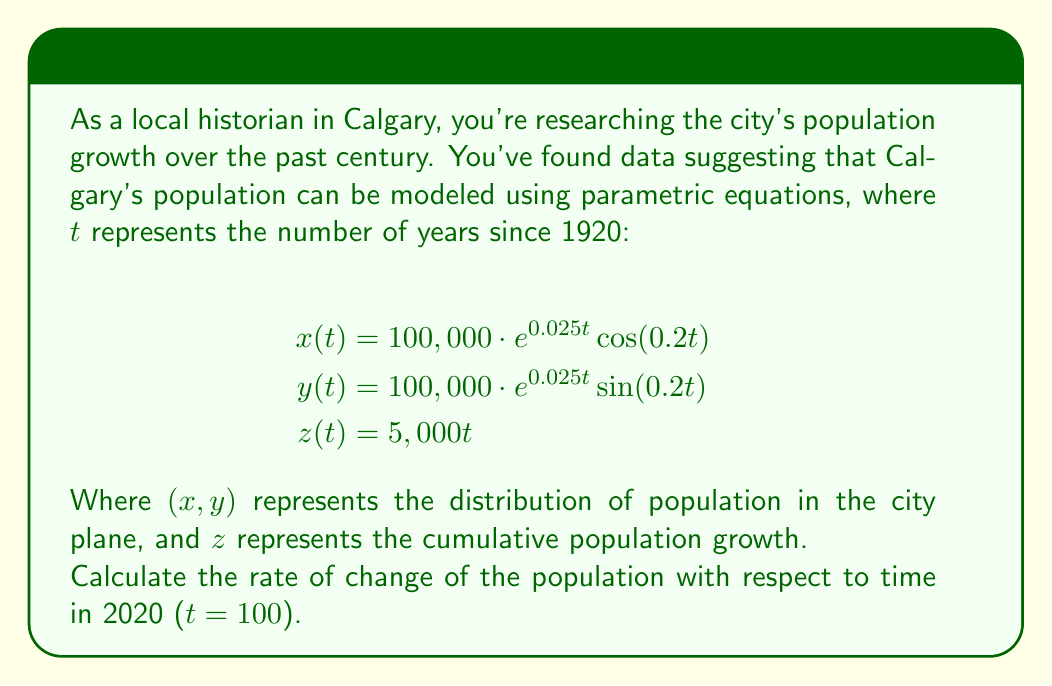Help me with this question. To solve this problem, we need to find the magnitude of the velocity vector at t = 100. The velocity vector is given by the derivative of the position vector with respect to t.

1) First, let's find the derivatives of x(t), y(t), and z(t):

   $$x'(t) = 100,000 \cdot (0.025e^{0.025t} \cos(0.2t) - 0.2e^{0.025t} \sin(0.2t))$$
   $$y'(t) = 100,000 \cdot (0.025e^{0.025t} \sin(0.2t) + 0.2e^{0.025t} \cos(0.2t))$$
   $$z'(t) = 5,000$$

2) The velocity vector at any time t is:
   $$\vec{v}(t) = \langle x'(t), y'(t), z'(t) \rangle$$

3) The magnitude of this vector gives us the rate of change of population:
   $$\text{Rate of change} = \|\vec{v}(t)\| = \sqrt{(x'(t))^2 + (y'(t))^2 + (z'(t))^2}$$

4) Now, let's substitute t = 100:
   $$x'(100) = 100,000 \cdot (0.025e^{2.5} \cos(20) - 0.2e^{2.5} \sin(20))$$
   $$y'(100) = 100,000 \cdot (0.025e^{2.5} \sin(20) + 0.2e^{2.5} \cos(20))$$
   $$z'(100) = 5,000$$

5) Calculate the magnitude:
   $$\text{Rate of change} = \sqrt{(x'(100))^2 + (y'(100))^2 + (5,000)^2}$$

6) Using a calculator for the numerical values:
   $$\text{Rate of change} \approx 1,226,106.95$$
Answer: The rate of change of Calgary's population in 2020 (t = 100) is approximately 1,226,107 people per year. 